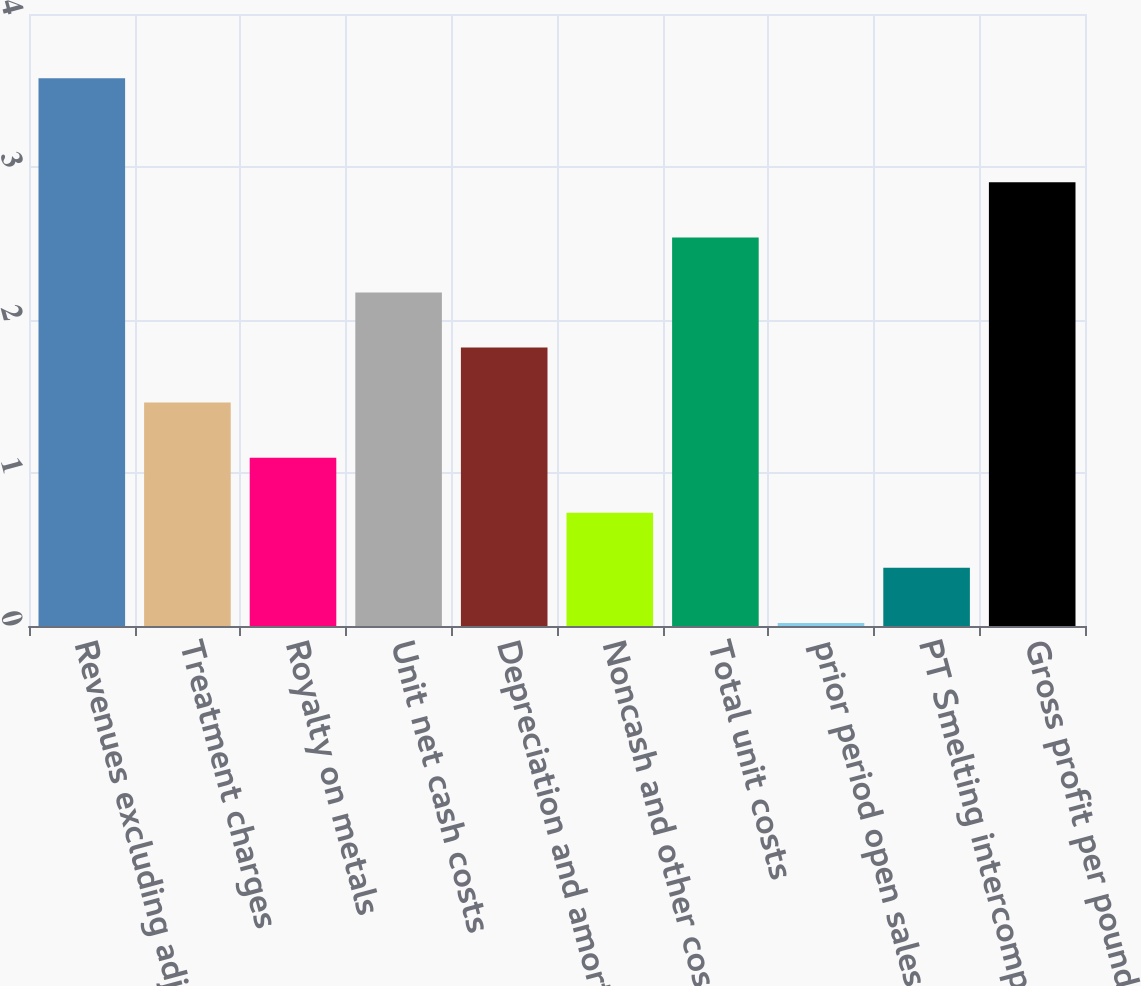<chart> <loc_0><loc_0><loc_500><loc_500><bar_chart><fcel>Revenues excluding adjustments<fcel>Treatment charges<fcel>Royalty on metals<fcel>Unit net cash costs<fcel>Depreciation and amortization<fcel>Noncash and other costs net<fcel>Total unit costs<fcel>prior period open sales<fcel>PT Smelting intercompany<fcel>Gross profit per pound/ounce<nl><fcel>3.58<fcel>1.46<fcel>1.1<fcel>2.18<fcel>1.82<fcel>0.74<fcel>2.54<fcel>0.02<fcel>0.38<fcel>2.9<nl></chart> 